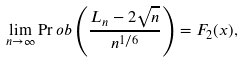<formula> <loc_0><loc_0><loc_500><loc_500>\lim _ { n \to \infty } \Pr o b \left ( \frac { L _ { n } - 2 \sqrt { n } } { n ^ { 1 / 6 } } \right ) = F _ { 2 } ( x ) ,</formula> 